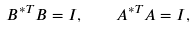Convert formula to latex. <formula><loc_0><loc_0><loc_500><loc_500>B ^ { * T } B = I , \quad A ^ { * T } A = I ,</formula> 